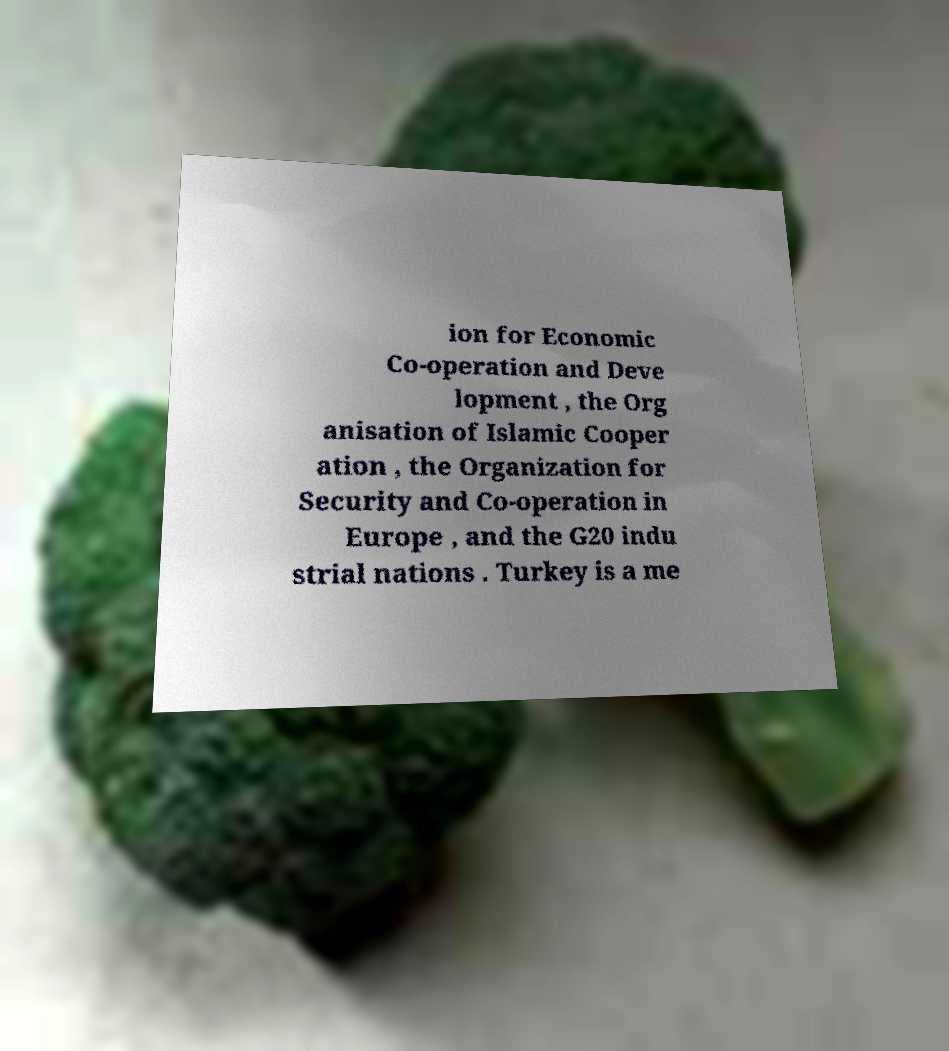I need the written content from this picture converted into text. Can you do that? ion for Economic Co-operation and Deve lopment , the Org anisation of Islamic Cooper ation , the Organization for Security and Co-operation in Europe , and the G20 indu strial nations . Turkey is a me 